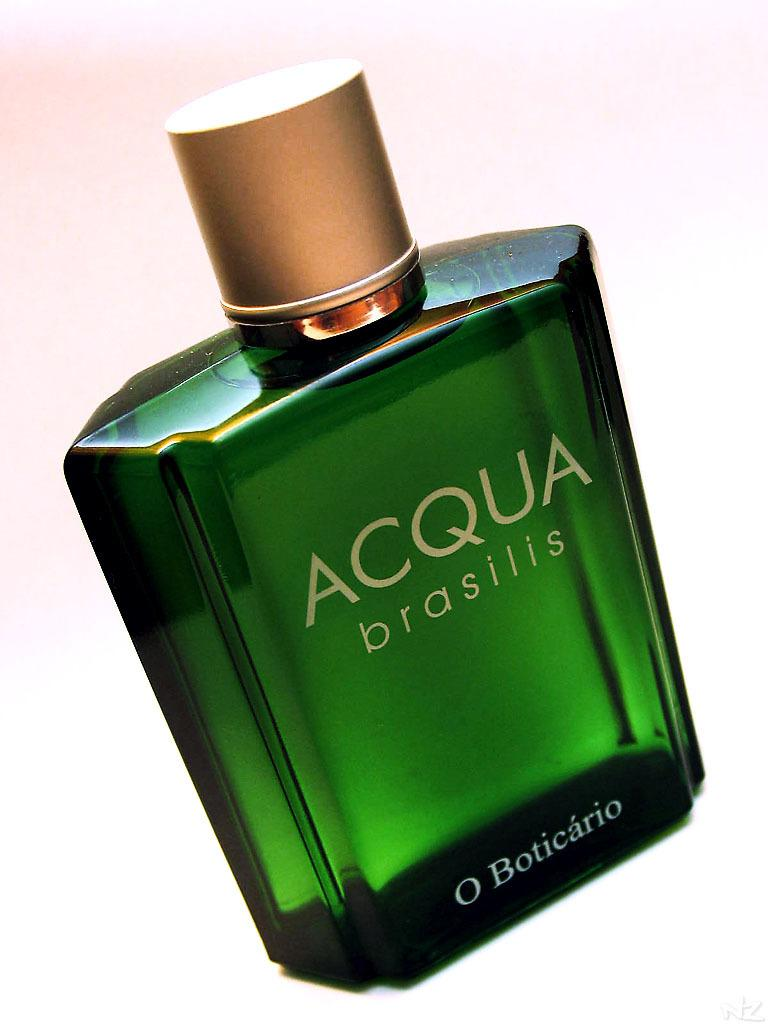<image>
Provide a brief description of the given image. A green perfume bottle with Acqua brasilis printed on it. 